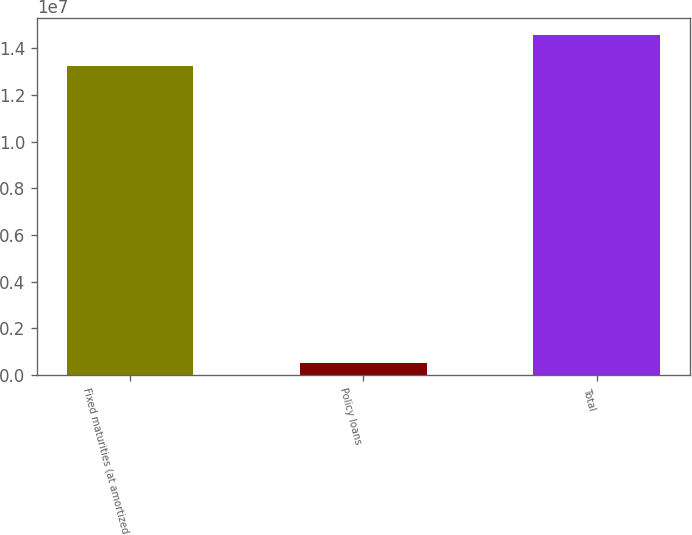Convert chart. <chart><loc_0><loc_0><loc_500><loc_500><bar_chart><fcel>Fixed maturities (at amortized<fcel>Policy loans<fcel>Total<nl><fcel>1.32519e+07<fcel>492462<fcel>1.45847e+07<nl></chart> 